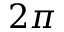Convert formula to latex. <formula><loc_0><loc_0><loc_500><loc_500>2 \pi</formula> 